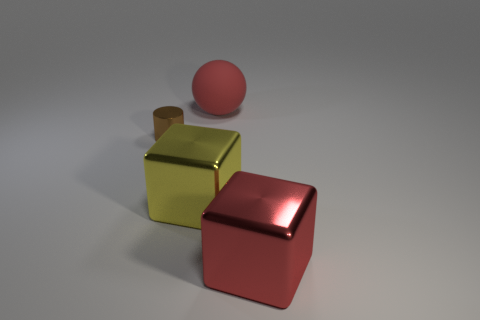What size is the shiny block that is the same color as the ball?
Make the answer very short. Large. There is a object that is both on the left side of the matte object and in front of the tiny brown metallic cylinder; how big is it?
Make the answer very short. Large. The big object that is to the right of the large red thing behind the tiny metal cylinder to the left of the yellow metal block is made of what material?
Your response must be concise. Metal. There is a block that is the same color as the big rubber ball; what is it made of?
Offer a terse response. Metal. Is the color of the big cube that is on the right side of the large red matte thing the same as the large object that is behind the small brown cylinder?
Provide a succinct answer. Yes. The big red thing behind the red object that is in front of the shiny thing left of the large yellow shiny thing is what shape?
Offer a terse response. Sphere. There is a thing that is both in front of the red rubber ball and to the right of the yellow object; what is its shape?
Give a very brief answer. Cube. What number of big things are behind the object that is on the right side of the big rubber sphere that is on the right side of the brown metal object?
Your answer should be compact. 2. The red thing that is the same shape as the big yellow thing is what size?
Keep it short and to the point. Large. Are there any other things that have the same size as the brown cylinder?
Keep it short and to the point. No. 